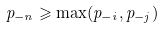<formula> <loc_0><loc_0><loc_500><loc_500>p _ { - n } \geqslant \max ( p _ { - i } , p _ { - j } )</formula> 